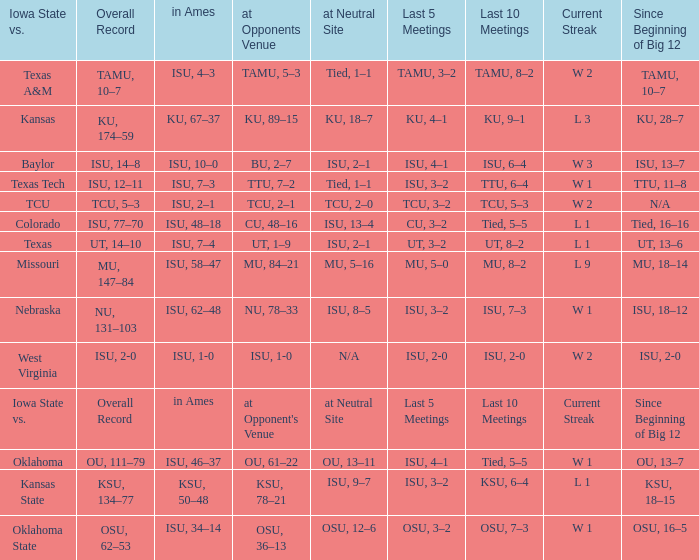When the value of "since beginning of big 12" is synonymous with its' category, what are the in Ames values? In ames. 